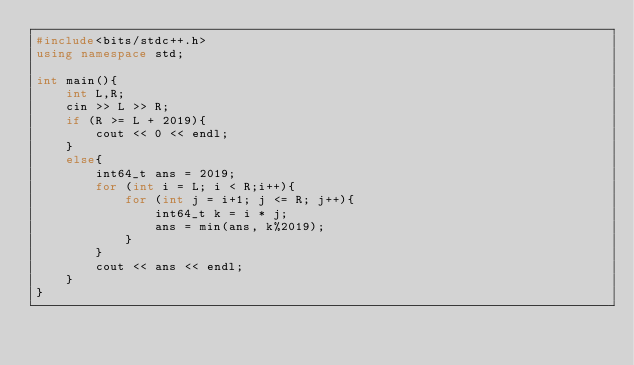<code> <loc_0><loc_0><loc_500><loc_500><_C++_>#include<bits/stdc++.h>
using namespace std;

int main(){
    int L,R;
    cin >> L >> R;
    if (R >= L + 2019){
        cout << 0 << endl;
    }
    else{
        int64_t ans = 2019;
        for (int i = L; i < R;i++){
            for (int j = i+1; j <= R; j++){
                int64_t k = i * j;
                ans = min(ans, k%2019);
            }
        }
        cout << ans << endl;
    }
}</code> 